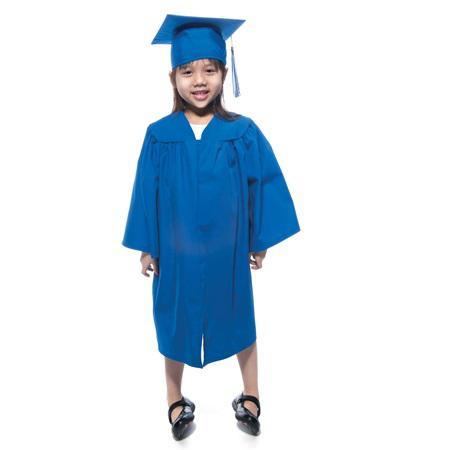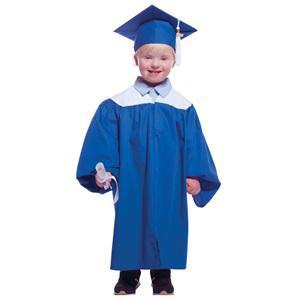The first image is the image on the left, the second image is the image on the right. Assess this claim about the two images: "Two people are dressed in a blue graduation cap and blue graduation gown". Correct or not? Answer yes or no. Yes. The first image is the image on the left, the second image is the image on the right. Evaluate the accuracy of this statement regarding the images: "A young girl wears a blue graduation robe and cap in one image.". Is it true? Answer yes or no. Yes. 